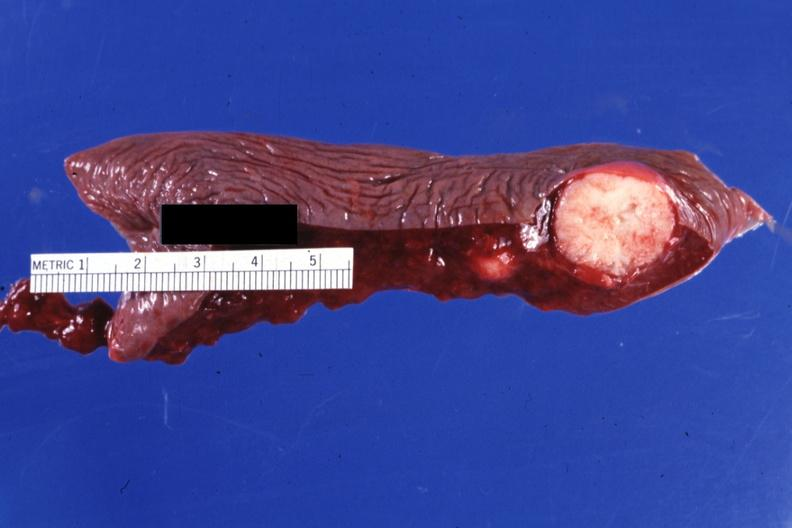s spleen present?
Answer the question using a single word or phrase. Yes 